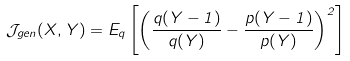Convert formula to latex. <formula><loc_0><loc_0><loc_500><loc_500>\mathcal { J } _ { g e n } ( X , Y ) = E _ { q } \left [ \left ( \frac { q ( Y - 1 ) } { q ( Y ) } - \frac { p ( Y - 1 ) } { p ( Y ) } \right ) ^ { 2 } \right ]</formula> 